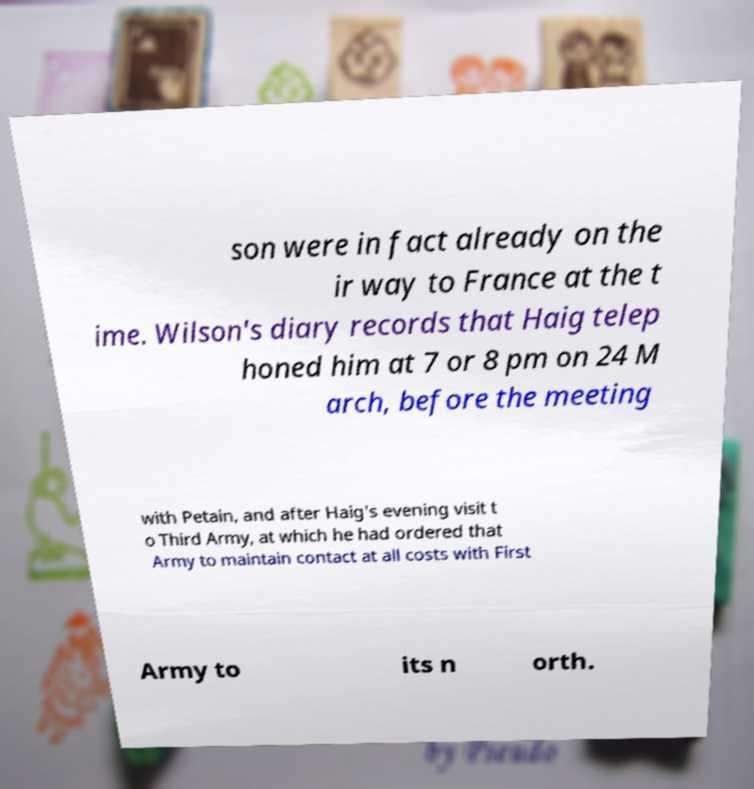Please read and relay the text visible in this image. What does it say? son were in fact already on the ir way to France at the t ime. Wilson's diary records that Haig telep honed him at 7 or 8 pm on 24 M arch, before the meeting with Petain, and after Haig's evening visit t o Third Army, at which he had ordered that Army to maintain contact at all costs with First Army to its n orth. 